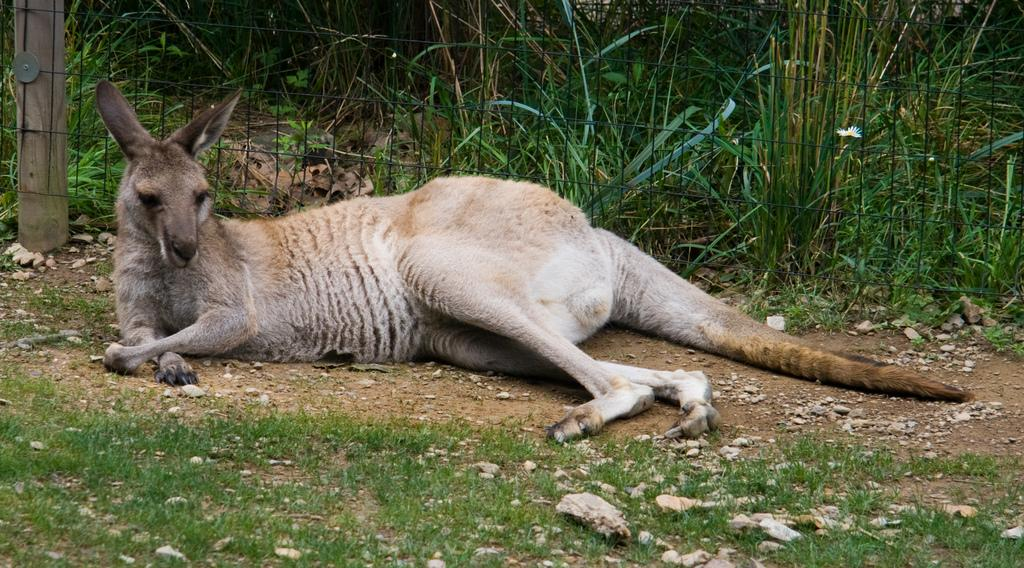What is the animal lying on the ground in the image? The animal lying on the ground in the image has white, black, and brown colors. What can be seen in the background of the image? There is railing and plants visible in the background of the image. What type of waste is the animal eating in the image? There is no waste present in the image, and the animal is not eating anything. 